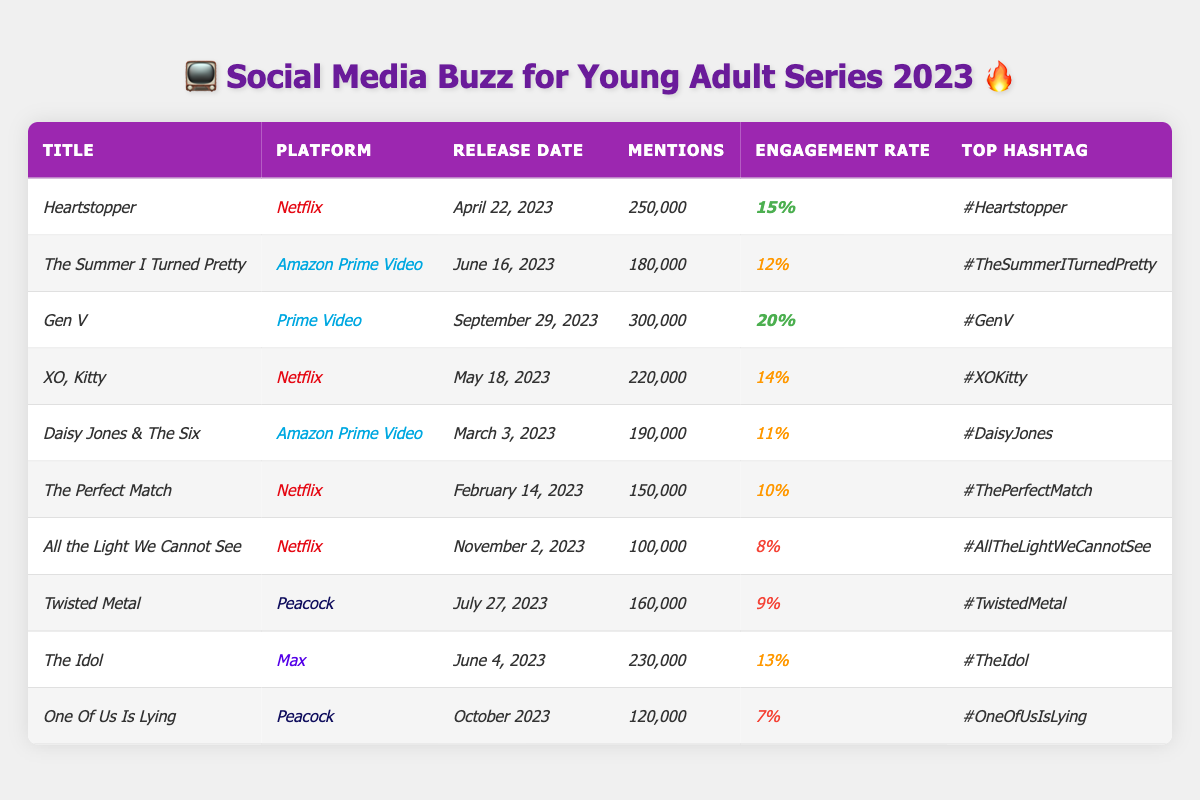What is the total number of social media mentions for all series combined? To find the total mentions, I need to sum the mentions of each series: 250,000 + 180,000 + 300,000 + 220,000 + 190,000 + 150,000 + 100,000 + 160,000 + 230,000 + 120,000 = 1,780,000.
Answer: 1,780,000 Which series has the highest engagement rate? By comparing the engagement rates, "Gen V" has the highest rate at 20%.
Answer: "Gen V" True or False: "The Perfect Match" has more mentions than "Daisy Jones & The Six." "The Perfect Match" has 150,000 mentions, while "Daisy Jones & The Six" has 190,000 mentions, so this statement is false.
Answer: False What is the average engagement rate of all the series listed? First, I add the engagement rates: 15% + 12% + 20% + 14% + 11% + 10% + 8% + 9% + 13% + 7% = 129%. There are 10 series, so the average is 129% / 10 = 12.9%.
Answer: 12.9% Which platform has the most series listed in the table? By counting, Netflix has 4 series, Amazon Prime Video has 3, Peacock has 2, and Max has 1. Thus, Netflix has the most series listed.
Answer: Netflix What is the difference in mentions between "Heartstopper" and "XO, Kitty"? "Heartstopper" has 250,000 mentions and "XO, Kitty" has 220,000 mentions. The difference is 250,000 - 220,000 = 30,000.
Answer: 30,000 Which series has the lowest engagement rate and what is it? "One Of Us Is Lying" has the lowest engagement rate at 7%.
Answer: 7% How many series were released on Netflix? There are 4 series listed under Netflix: "Heartstopper," "XO, Kitty," "The Perfect Match," and "All the Light We Cannot See."
Answer: 4 Which series was released most recently and on which platform? "One Of Us Is Lying" was released in October 2023 on Peacock, making it the most recent release.
Answer: "One Of Us Is Lying" on Peacock What is the total number of mentions for all Amazon Prime Video series combined? The Amazon Prime Video series are "The Summer I Turned Pretty" (180,000) and "Daisy Jones & The Six" (190,000). In total, 180,000 + 190,000 = 370,000 mentions.
Answer: 370,000 